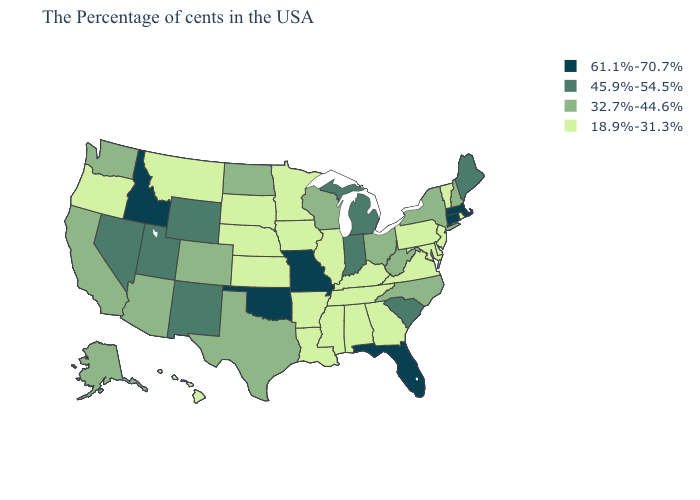Does Mississippi have the highest value in the South?
Answer briefly. No. Name the states that have a value in the range 45.9%-54.5%?
Be succinct. Maine, South Carolina, Michigan, Indiana, Wyoming, New Mexico, Utah, Nevada. What is the value of Arkansas?
Keep it brief. 18.9%-31.3%. What is the value of Iowa?
Write a very short answer. 18.9%-31.3%. Among the states that border Idaho , does Washington have the highest value?
Write a very short answer. No. Does Hawaii have the lowest value in the USA?
Concise answer only. Yes. Name the states that have a value in the range 32.7%-44.6%?
Be succinct. New Hampshire, New York, North Carolina, West Virginia, Ohio, Wisconsin, Texas, North Dakota, Colorado, Arizona, California, Washington, Alaska. Which states have the lowest value in the Northeast?
Be succinct. Rhode Island, Vermont, New Jersey, Pennsylvania. What is the value of Wyoming?
Short answer required. 45.9%-54.5%. Name the states that have a value in the range 45.9%-54.5%?
Keep it brief. Maine, South Carolina, Michigan, Indiana, Wyoming, New Mexico, Utah, Nevada. Name the states that have a value in the range 45.9%-54.5%?
Write a very short answer. Maine, South Carolina, Michigan, Indiana, Wyoming, New Mexico, Utah, Nevada. Name the states that have a value in the range 61.1%-70.7%?
Concise answer only. Massachusetts, Connecticut, Florida, Missouri, Oklahoma, Idaho. Does the map have missing data?
Quick response, please. No. Name the states that have a value in the range 18.9%-31.3%?
Quick response, please. Rhode Island, Vermont, New Jersey, Delaware, Maryland, Pennsylvania, Virginia, Georgia, Kentucky, Alabama, Tennessee, Illinois, Mississippi, Louisiana, Arkansas, Minnesota, Iowa, Kansas, Nebraska, South Dakota, Montana, Oregon, Hawaii. Among the states that border Iowa , does Missouri have the highest value?
Write a very short answer. Yes. 